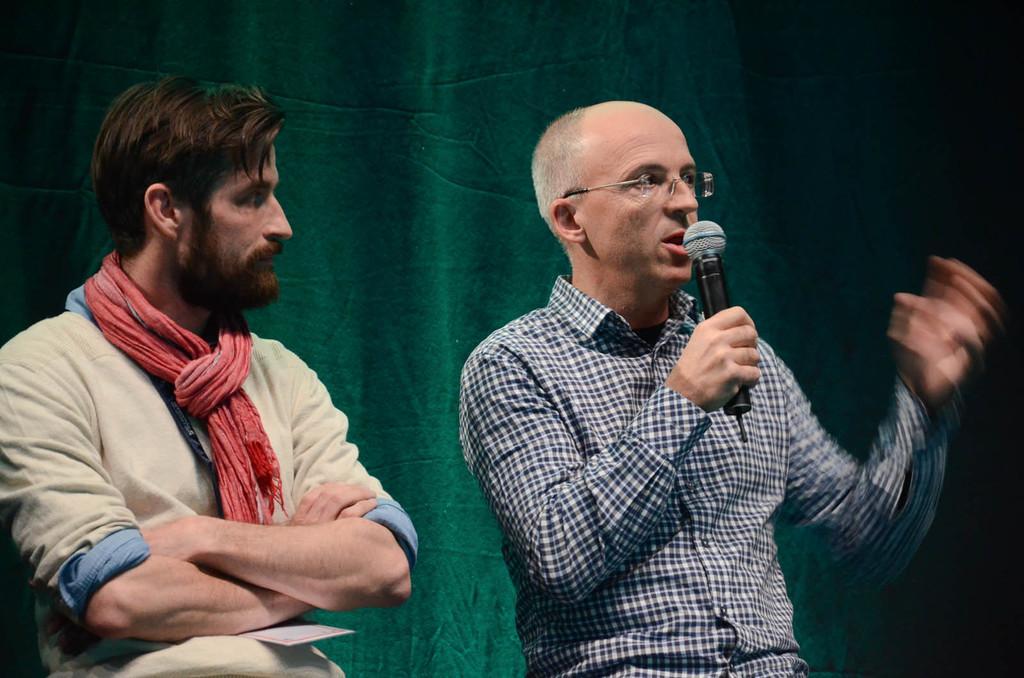Could you give a brief overview of what you see in this image? This image consists of two persons, one is standing on the left side and the other one is standing on the right side. The one who is on the right side is holding Mike and talking something. He is wearing black and white shirt. the one on the left side is wearing a scarf. There is a green color cloth behind them. 